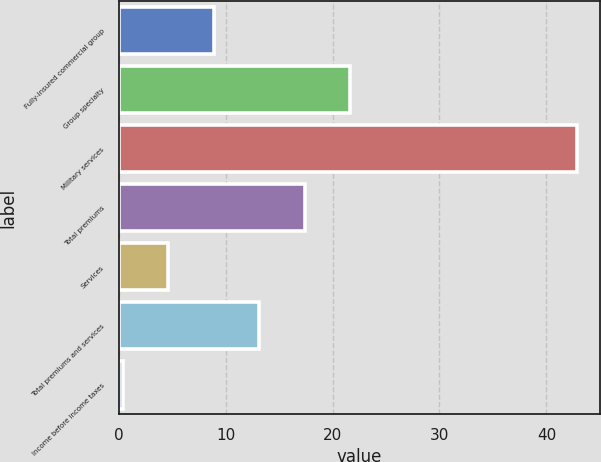<chart> <loc_0><loc_0><loc_500><loc_500><bar_chart><fcel>Fully-insured commercial group<fcel>Group specialty<fcel>Military services<fcel>Total premiums<fcel>Services<fcel>Total premiums and services<fcel>Income before income taxes<nl><fcel>8.9<fcel>21.65<fcel>42.9<fcel>17.4<fcel>4.65<fcel>13.15<fcel>0.4<nl></chart> 